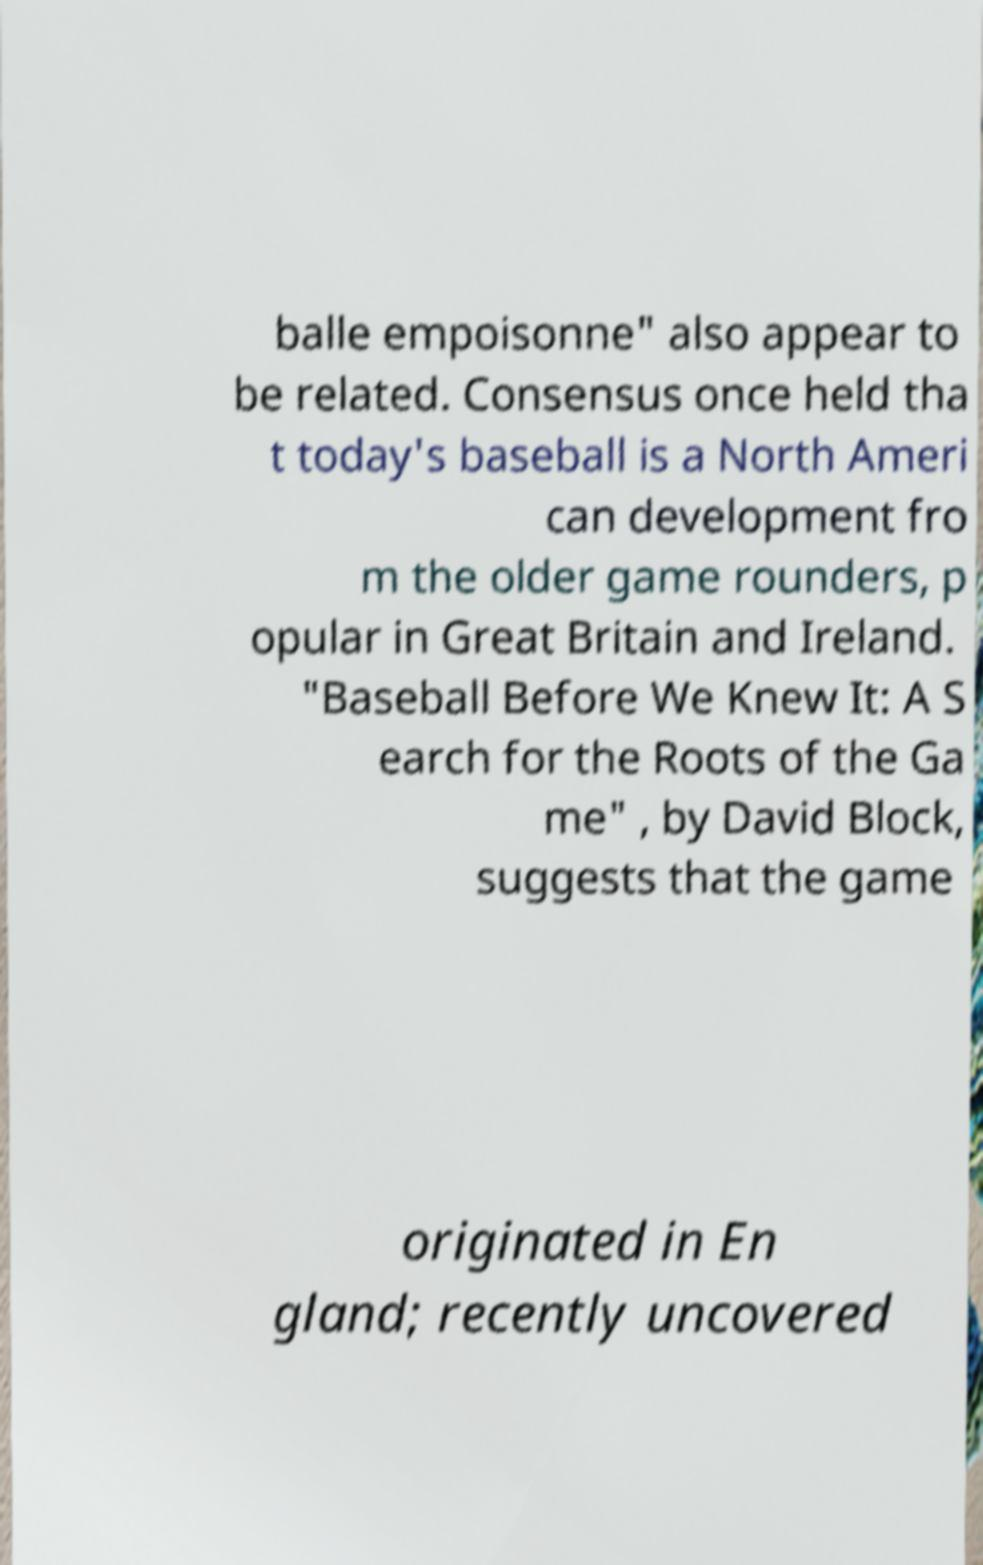Could you assist in decoding the text presented in this image and type it out clearly? balle empoisonne" also appear to be related. Consensus once held tha t today's baseball is a North Ameri can development fro m the older game rounders, p opular in Great Britain and Ireland. "Baseball Before We Knew It: A S earch for the Roots of the Ga me" , by David Block, suggests that the game originated in En gland; recently uncovered 